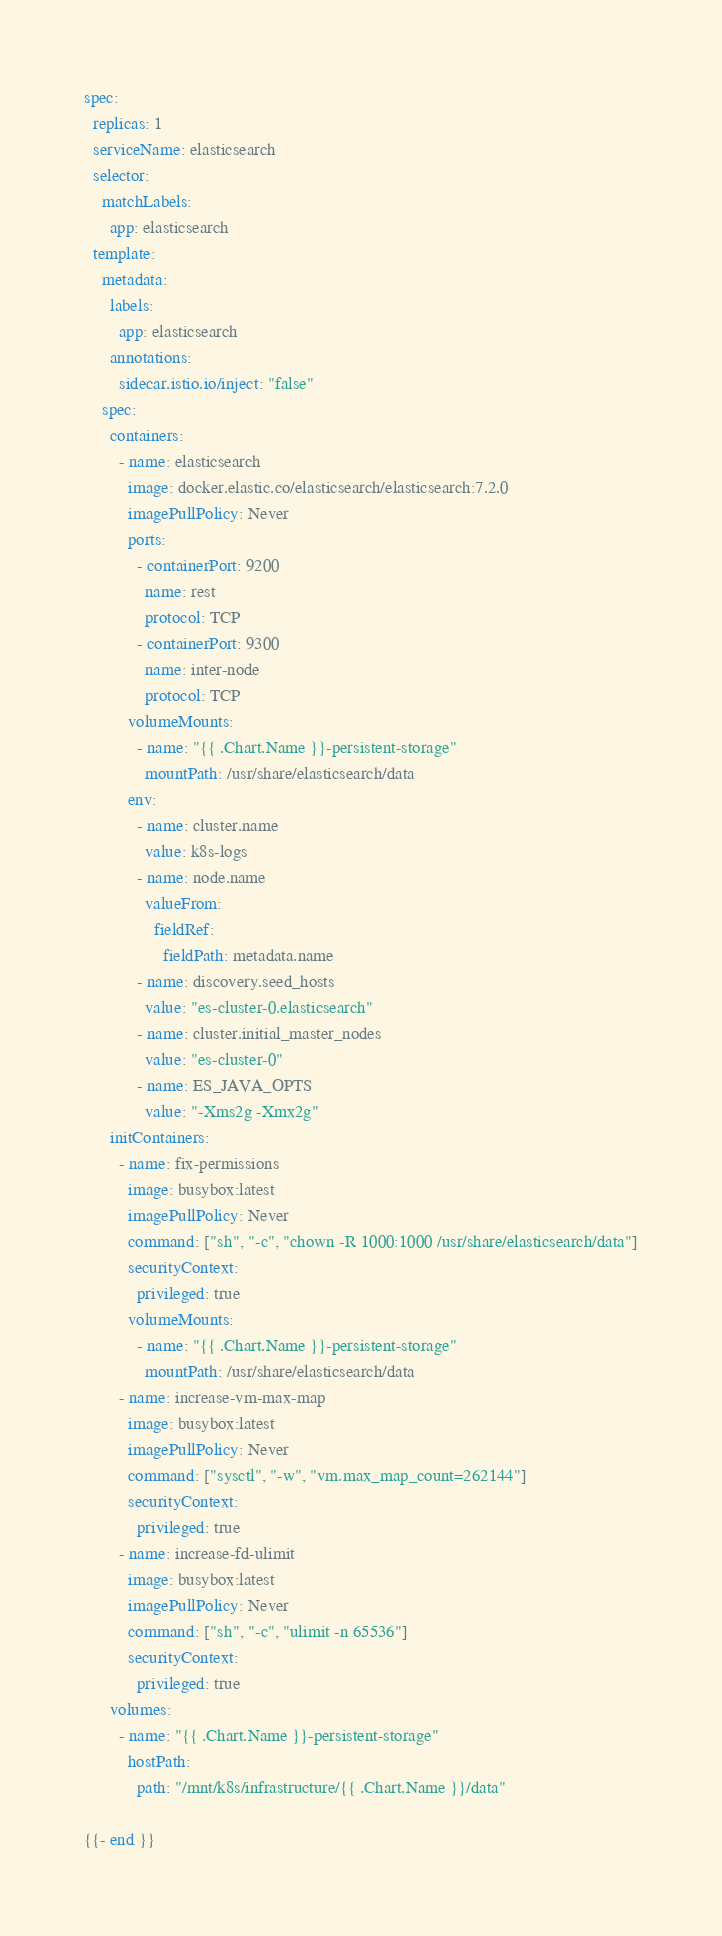<code> <loc_0><loc_0><loc_500><loc_500><_YAML_>spec:
  replicas: 1
  serviceName: elasticsearch
  selector:
    matchLabels:
      app: elasticsearch
  template:
    metadata:
      labels:
        app: elasticsearch
      annotations:
        sidecar.istio.io/inject: "false"
    spec:
      containers:
        - name: elasticsearch
          image: docker.elastic.co/elasticsearch/elasticsearch:7.2.0
          imagePullPolicy: Never
          ports:
            - containerPort: 9200
              name: rest
              protocol: TCP
            - containerPort: 9300
              name: inter-node
              protocol: TCP
          volumeMounts:
            - name: "{{ .Chart.Name }}-persistent-storage"
              mountPath: /usr/share/elasticsearch/data
          env:
            - name: cluster.name
              value: k8s-logs
            - name: node.name
              valueFrom:
                fieldRef:
                  fieldPath: metadata.name
            - name: discovery.seed_hosts
              value: "es-cluster-0.elasticsearch"
            - name: cluster.initial_master_nodes
              value: "es-cluster-0"
            - name: ES_JAVA_OPTS
              value: "-Xms2g -Xmx2g"
      initContainers:
        - name: fix-permissions
          image: busybox:latest
          imagePullPolicy: Never
          command: ["sh", "-c", "chown -R 1000:1000 /usr/share/elasticsearch/data"]
          securityContext:
            privileged: true
          volumeMounts:
            - name: "{{ .Chart.Name }}-persistent-storage"
              mountPath: /usr/share/elasticsearch/data
        - name: increase-vm-max-map
          image: busybox:latest
          imagePullPolicy: Never
          command: ["sysctl", "-w", "vm.max_map_count=262144"]
          securityContext:
            privileged: true
        - name: increase-fd-ulimit
          image: busybox:latest
          imagePullPolicy: Never
          command: ["sh", "-c", "ulimit -n 65536"]
          securityContext:
            privileged: true
      volumes:
        - name: "{{ .Chart.Name }}-persistent-storage"
          hostPath:
            path: "/mnt/k8s/infrastructure/{{ .Chart.Name }}/data"

{{- end }}
</code> 